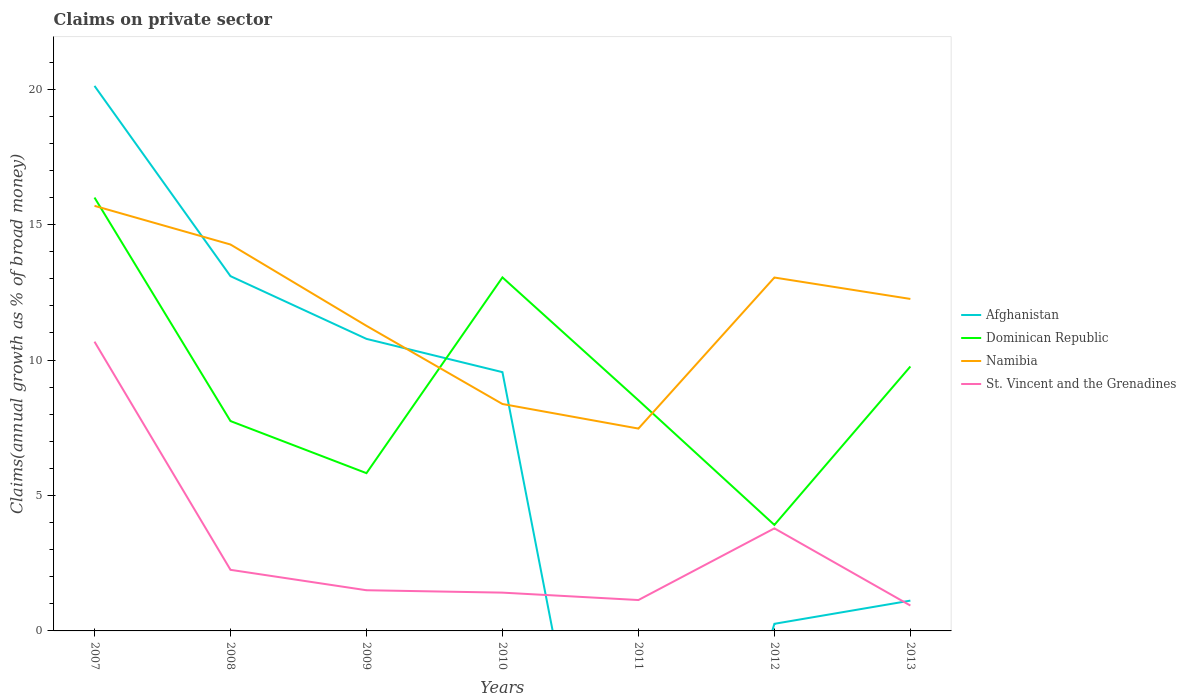Does the line corresponding to Dominican Republic intersect with the line corresponding to St. Vincent and the Grenadines?
Keep it short and to the point. No. Across all years, what is the maximum percentage of broad money claimed on private sector in Namibia?
Keep it short and to the point. 7.47. What is the total percentage of broad money claimed on private sector in Dominican Republic in the graph?
Keep it short and to the point. -5.85. What is the difference between the highest and the second highest percentage of broad money claimed on private sector in Namibia?
Keep it short and to the point. 8.22. What is the difference between the highest and the lowest percentage of broad money claimed on private sector in Namibia?
Your answer should be compact. 4. Is the percentage of broad money claimed on private sector in Namibia strictly greater than the percentage of broad money claimed on private sector in Afghanistan over the years?
Offer a very short reply. No. What is the difference between two consecutive major ticks on the Y-axis?
Your answer should be very brief. 5. Are the values on the major ticks of Y-axis written in scientific E-notation?
Your answer should be compact. No. Does the graph contain grids?
Your answer should be very brief. No. How are the legend labels stacked?
Keep it short and to the point. Vertical. What is the title of the graph?
Give a very brief answer. Claims on private sector. What is the label or title of the X-axis?
Keep it short and to the point. Years. What is the label or title of the Y-axis?
Your answer should be compact. Claims(annual growth as % of broad money). What is the Claims(annual growth as % of broad money) in Afghanistan in 2007?
Offer a very short reply. 20.12. What is the Claims(annual growth as % of broad money) in Dominican Republic in 2007?
Provide a short and direct response. 16. What is the Claims(annual growth as % of broad money) in Namibia in 2007?
Offer a terse response. 15.69. What is the Claims(annual growth as % of broad money) in St. Vincent and the Grenadines in 2007?
Give a very brief answer. 10.68. What is the Claims(annual growth as % of broad money) of Afghanistan in 2008?
Your response must be concise. 13.1. What is the Claims(annual growth as % of broad money) of Dominican Republic in 2008?
Offer a terse response. 7.75. What is the Claims(annual growth as % of broad money) in Namibia in 2008?
Give a very brief answer. 14.27. What is the Claims(annual growth as % of broad money) of St. Vincent and the Grenadines in 2008?
Your answer should be compact. 2.26. What is the Claims(annual growth as % of broad money) in Afghanistan in 2009?
Provide a succinct answer. 10.78. What is the Claims(annual growth as % of broad money) in Dominican Republic in 2009?
Ensure brevity in your answer.  5.82. What is the Claims(annual growth as % of broad money) in Namibia in 2009?
Your answer should be compact. 11.26. What is the Claims(annual growth as % of broad money) in St. Vincent and the Grenadines in 2009?
Your answer should be compact. 1.5. What is the Claims(annual growth as % of broad money) of Afghanistan in 2010?
Offer a very short reply. 9.55. What is the Claims(annual growth as % of broad money) of Dominican Republic in 2010?
Offer a very short reply. 13.05. What is the Claims(annual growth as % of broad money) of Namibia in 2010?
Your answer should be compact. 8.38. What is the Claims(annual growth as % of broad money) in St. Vincent and the Grenadines in 2010?
Keep it short and to the point. 1.41. What is the Claims(annual growth as % of broad money) of Afghanistan in 2011?
Keep it short and to the point. 0. What is the Claims(annual growth as % of broad money) in Dominican Republic in 2011?
Your response must be concise. 8.51. What is the Claims(annual growth as % of broad money) of Namibia in 2011?
Keep it short and to the point. 7.47. What is the Claims(annual growth as % of broad money) of St. Vincent and the Grenadines in 2011?
Provide a short and direct response. 1.14. What is the Claims(annual growth as % of broad money) of Afghanistan in 2012?
Make the answer very short. 0.26. What is the Claims(annual growth as % of broad money) of Dominican Republic in 2012?
Provide a short and direct response. 3.91. What is the Claims(annual growth as % of broad money) in Namibia in 2012?
Offer a terse response. 13.05. What is the Claims(annual growth as % of broad money) in St. Vincent and the Grenadines in 2012?
Your response must be concise. 3.79. What is the Claims(annual growth as % of broad money) of Afghanistan in 2013?
Keep it short and to the point. 1.12. What is the Claims(annual growth as % of broad money) in Dominican Republic in 2013?
Your answer should be very brief. 9.76. What is the Claims(annual growth as % of broad money) in Namibia in 2013?
Give a very brief answer. 12.26. What is the Claims(annual growth as % of broad money) of St. Vincent and the Grenadines in 2013?
Offer a very short reply. 0.94. Across all years, what is the maximum Claims(annual growth as % of broad money) in Afghanistan?
Ensure brevity in your answer.  20.12. Across all years, what is the maximum Claims(annual growth as % of broad money) in Dominican Republic?
Your answer should be very brief. 16. Across all years, what is the maximum Claims(annual growth as % of broad money) in Namibia?
Offer a terse response. 15.69. Across all years, what is the maximum Claims(annual growth as % of broad money) of St. Vincent and the Grenadines?
Give a very brief answer. 10.68. Across all years, what is the minimum Claims(annual growth as % of broad money) in Afghanistan?
Provide a short and direct response. 0. Across all years, what is the minimum Claims(annual growth as % of broad money) in Dominican Republic?
Your answer should be very brief. 3.91. Across all years, what is the minimum Claims(annual growth as % of broad money) of Namibia?
Make the answer very short. 7.47. Across all years, what is the minimum Claims(annual growth as % of broad money) of St. Vincent and the Grenadines?
Provide a short and direct response. 0.94. What is the total Claims(annual growth as % of broad money) in Afghanistan in the graph?
Provide a short and direct response. 54.93. What is the total Claims(annual growth as % of broad money) in Dominican Republic in the graph?
Make the answer very short. 64.81. What is the total Claims(annual growth as % of broad money) of Namibia in the graph?
Your answer should be compact. 82.37. What is the total Claims(annual growth as % of broad money) of St. Vincent and the Grenadines in the graph?
Your answer should be compact. 21.71. What is the difference between the Claims(annual growth as % of broad money) in Afghanistan in 2007 and that in 2008?
Your answer should be compact. 7.02. What is the difference between the Claims(annual growth as % of broad money) in Dominican Republic in 2007 and that in 2008?
Give a very brief answer. 8.25. What is the difference between the Claims(annual growth as % of broad money) of Namibia in 2007 and that in 2008?
Your answer should be compact. 1.43. What is the difference between the Claims(annual growth as % of broad money) in St. Vincent and the Grenadines in 2007 and that in 2008?
Provide a succinct answer. 8.42. What is the difference between the Claims(annual growth as % of broad money) in Afghanistan in 2007 and that in 2009?
Keep it short and to the point. 9.34. What is the difference between the Claims(annual growth as % of broad money) in Dominican Republic in 2007 and that in 2009?
Keep it short and to the point. 10.17. What is the difference between the Claims(annual growth as % of broad money) of Namibia in 2007 and that in 2009?
Provide a short and direct response. 4.43. What is the difference between the Claims(annual growth as % of broad money) of St. Vincent and the Grenadines in 2007 and that in 2009?
Ensure brevity in your answer.  9.18. What is the difference between the Claims(annual growth as % of broad money) in Afghanistan in 2007 and that in 2010?
Offer a terse response. 10.57. What is the difference between the Claims(annual growth as % of broad money) in Dominican Republic in 2007 and that in 2010?
Make the answer very short. 2.95. What is the difference between the Claims(annual growth as % of broad money) of Namibia in 2007 and that in 2010?
Offer a terse response. 7.32. What is the difference between the Claims(annual growth as % of broad money) in St. Vincent and the Grenadines in 2007 and that in 2010?
Offer a very short reply. 9.26. What is the difference between the Claims(annual growth as % of broad money) in Dominican Republic in 2007 and that in 2011?
Offer a very short reply. 7.48. What is the difference between the Claims(annual growth as % of broad money) in Namibia in 2007 and that in 2011?
Make the answer very short. 8.22. What is the difference between the Claims(annual growth as % of broad money) in St. Vincent and the Grenadines in 2007 and that in 2011?
Provide a succinct answer. 9.54. What is the difference between the Claims(annual growth as % of broad money) of Afghanistan in 2007 and that in 2012?
Your answer should be very brief. 19.86. What is the difference between the Claims(annual growth as % of broad money) in Dominican Republic in 2007 and that in 2012?
Offer a very short reply. 12.09. What is the difference between the Claims(annual growth as % of broad money) of Namibia in 2007 and that in 2012?
Provide a short and direct response. 2.65. What is the difference between the Claims(annual growth as % of broad money) in St. Vincent and the Grenadines in 2007 and that in 2012?
Your response must be concise. 6.89. What is the difference between the Claims(annual growth as % of broad money) of Afghanistan in 2007 and that in 2013?
Provide a succinct answer. 19. What is the difference between the Claims(annual growth as % of broad money) of Dominican Republic in 2007 and that in 2013?
Provide a short and direct response. 6.24. What is the difference between the Claims(annual growth as % of broad money) in Namibia in 2007 and that in 2013?
Your answer should be compact. 3.44. What is the difference between the Claims(annual growth as % of broad money) of St. Vincent and the Grenadines in 2007 and that in 2013?
Your answer should be compact. 9.74. What is the difference between the Claims(annual growth as % of broad money) in Afghanistan in 2008 and that in 2009?
Your response must be concise. 2.31. What is the difference between the Claims(annual growth as % of broad money) in Dominican Republic in 2008 and that in 2009?
Keep it short and to the point. 1.92. What is the difference between the Claims(annual growth as % of broad money) of Namibia in 2008 and that in 2009?
Your answer should be compact. 3. What is the difference between the Claims(annual growth as % of broad money) in St. Vincent and the Grenadines in 2008 and that in 2009?
Offer a very short reply. 0.75. What is the difference between the Claims(annual growth as % of broad money) in Afghanistan in 2008 and that in 2010?
Provide a succinct answer. 3.54. What is the difference between the Claims(annual growth as % of broad money) in Dominican Republic in 2008 and that in 2010?
Your answer should be compact. -5.3. What is the difference between the Claims(annual growth as % of broad money) of Namibia in 2008 and that in 2010?
Your response must be concise. 5.89. What is the difference between the Claims(annual growth as % of broad money) in St. Vincent and the Grenadines in 2008 and that in 2010?
Make the answer very short. 0.84. What is the difference between the Claims(annual growth as % of broad money) of Dominican Republic in 2008 and that in 2011?
Provide a short and direct response. -0.77. What is the difference between the Claims(annual growth as % of broad money) in Namibia in 2008 and that in 2011?
Your response must be concise. 6.8. What is the difference between the Claims(annual growth as % of broad money) in St. Vincent and the Grenadines in 2008 and that in 2011?
Your response must be concise. 1.12. What is the difference between the Claims(annual growth as % of broad money) of Afghanistan in 2008 and that in 2012?
Your answer should be compact. 12.83. What is the difference between the Claims(annual growth as % of broad money) in Dominican Republic in 2008 and that in 2012?
Offer a terse response. 3.83. What is the difference between the Claims(annual growth as % of broad money) of Namibia in 2008 and that in 2012?
Offer a terse response. 1.22. What is the difference between the Claims(annual growth as % of broad money) of St. Vincent and the Grenadines in 2008 and that in 2012?
Your response must be concise. -1.53. What is the difference between the Claims(annual growth as % of broad money) in Afghanistan in 2008 and that in 2013?
Offer a very short reply. 11.98. What is the difference between the Claims(annual growth as % of broad money) in Dominican Republic in 2008 and that in 2013?
Offer a terse response. -2.01. What is the difference between the Claims(annual growth as % of broad money) of Namibia in 2008 and that in 2013?
Keep it short and to the point. 2.01. What is the difference between the Claims(annual growth as % of broad money) in St. Vincent and the Grenadines in 2008 and that in 2013?
Your response must be concise. 1.32. What is the difference between the Claims(annual growth as % of broad money) of Afghanistan in 2009 and that in 2010?
Offer a terse response. 1.23. What is the difference between the Claims(annual growth as % of broad money) in Dominican Republic in 2009 and that in 2010?
Your answer should be compact. -7.23. What is the difference between the Claims(annual growth as % of broad money) of Namibia in 2009 and that in 2010?
Offer a terse response. 2.89. What is the difference between the Claims(annual growth as % of broad money) in St. Vincent and the Grenadines in 2009 and that in 2010?
Provide a succinct answer. 0.09. What is the difference between the Claims(annual growth as % of broad money) in Dominican Republic in 2009 and that in 2011?
Your answer should be very brief. -2.69. What is the difference between the Claims(annual growth as % of broad money) in Namibia in 2009 and that in 2011?
Provide a short and direct response. 3.79. What is the difference between the Claims(annual growth as % of broad money) of St. Vincent and the Grenadines in 2009 and that in 2011?
Offer a terse response. 0.36. What is the difference between the Claims(annual growth as % of broad money) of Afghanistan in 2009 and that in 2012?
Provide a succinct answer. 10.52. What is the difference between the Claims(annual growth as % of broad money) in Dominican Republic in 2009 and that in 2012?
Give a very brief answer. 1.91. What is the difference between the Claims(annual growth as % of broad money) in Namibia in 2009 and that in 2012?
Your answer should be very brief. -1.78. What is the difference between the Claims(annual growth as % of broad money) of St. Vincent and the Grenadines in 2009 and that in 2012?
Your answer should be very brief. -2.28. What is the difference between the Claims(annual growth as % of broad money) in Afghanistan in 2009 and that in 2013?
Offer a very short reply. 9.66. What is the difference between the Claims(annual growth as % of broad money) in Dominican Republic in 2009 and that in 2013?
Provide a succinct answer. -3.94. What is the difference between the Claims(annual growth as % of broad money) in Namibia in 2009 and that in 2013?
Your response must be concise. -0.99. What is the difference between the Claims(annual growth as % of broad money) of St. Vincent and the Grenadines in 2009 and that in 2013?
Offer a terse response. 0.56. What is the difference between the Claims(annual growth as % of broad money) of Dominican Republic in 2010 and that in 2011?
Your answer should be very brief. 4.54. What is the difference between the Claims(annual growth as % of broad money) of Namibia in 2010 and that in 2011?
Your response must be concise. 0.91. What is the difference between the Claims(annual growth as % of broad money) of St. Vincent and the Grenadines in 2010 and that in 2011?
Your response must be concise. 0.27. What is the difference between the Claims(annual growth as % of broad money) in Afghanistan in 2010 and that in 2012?
Give a very brief answer. 9.29. What is the difference between the Claims(annual growth as % of broad money) in Dominican Republic in 2010 and that in 2012?
Offer a very short reply. 9.14. What is the difference between the Claims(annual growth as % of broad money) of Namibia in 2010 and that in 2012?
Provide a succinct answer. -4.67. What is the difference between the Claims(annual growth as % of broad money) in St. Vincent and the Grenadines in 2010 and that in 2012?
Give a very brief answer. -2.37. What is the difference between the Claims(annual growth as % of broad money) in Afghanistan in 2010 and that in 2013?
Your response must be concise. 8.43. What is the difference between the Claims(annual growth as % of broad money) of Dominican Republic in 2010 and that in 2013?
Give a very brief answer. 3.29. What is the difference between the Claims(annual growth as % of broad money) in Namibia in 2010 and that in 2013?
Ensure brevity in your answer.  -3.88. What is the difference between the Claims(annual growth as % of broad money) in St. Vincent and the Grenadines in 2010 and that in 2013?
Ensure brevity in your answer.  0.48. What is the difference between the Claims(annual growth as % of broad money) in Dominican Republic in 2011 and that in 2012?
Offer a terse response. 4.6. What is the difference between the Claims(annual growth as % of broad money) of Namibia in 2011 and that in 2012?
Make the answer very short. -5.58. What is the difference between the Claims(annual growth as % of broad money) in St. Vincent and the Grenadines in 2011 and that in 2012?
Provide a succinct answer. -2.65. What is the difference between the Claims(annual growth as % of broad money) of Dominican Republic in 2011 and that in 2013?
Provide a short and direct response. -1.25. What is the difference between the Claims(annual growth as % of broad money) of Namibia in 2011 and that in 2013?
Your answer should be compact. -4.79. What is the difference between the Claims(annual growth as % of broad money) in St. Vincent and the Grenadines in 2011 and that in 2013?
Your response must be concise. 0.2. What is the difference between the Claims(annual growth as % of broad money) of Afghanistan in 2012 and that in 2013?
Your answer should be compact. -0.86. What is the difference between the Claims(annual growth as % of broad money) of Dominican Republic in 2012 and that in 2013?
Give a very brief answer. -5.85. What is the difference between the Claims(annual growth as % of broad money) in Namibia in 2012 and that in 2013?
Your answer should be very brief. 0.79. What is the difference between the Claims(annual growth as % of broad money) in St. Vincent and the Grenadines in 2012 and that in 2013?
Your answer should be compact. 2.85. What is the difference between the Claims(annual growth as % of broad money) in Afghanistan in 2007 and the Claims(annual growth as % of broad money) in Dominican Republic in 2008?
Give a very brief answer. 12.37. What is the difference between the Claims(annual growth as % of broad money) in Afghanistan in 2007 and the Claims(annual growth as % of broad money) in Namibia in 2008?
Your answer should be very brief. 5.85. What is the difference between the Claims(annual growth as % of broad money) in Afghanistan in 2007 and the Claims(annual growth as % of broad money) in St. Vincent and the Grenadines in 2008?
Offer a terse response. 17.86. What is the difference between the Claims(annual growth as % of broad money) of Dominican Republic in 2007 and the Claims(annual growth as % of broad money) of Namibia in 2008?
Provide a succinct answer. 1.73. What is the difference between the Claims(annual growth as % of broad money) of Dominican Republic in 2007 and the Claims(annual growth as % of broad money) of St. Vincent and the Grenadines in 2008?
Make the answer very short. 13.74. What is the difference between the Claims(annual growth as % of broad money) in Namibia in 2007 and the Claims(annual growth as % of broad money) in St. Vincent and the Grenadines in 2008?
Provide a succinct answer. 13.44. What is the difference between the Claims(annual growth as % of broad money) of Afghanistan in 2007 and the Claims(annual growth as % of broad money) of Dominican Republic in 2009?
Ensure brevity in your answer.  14.3. What is the difference between the Claims(annual growth as % of broad money) of Afghanistan in 2007 and the Claims(annual growth as % of broad money) of Namibia in 2009?
Provide a short and direct response. 8.86. What is the difference between the Claims(annual growth as % of broad money) of Afghanistan in 2007 and the Claims(annual growth as % of broad money) of St. Vincent and the Grenadines in 2009?
Give a very brief answer. 18.62. What is the difference between the Claims(annual growth as % of broad money) of Dominican Republic in 2007 and the Claims(annual growth as % of broad money) of Namibia in 2009?
Your answer should be compact. 4.74. What is the difference between the Claims(annual growth as % of broad money) of Dominican Republic in 2007 and the Claims(annual growth as % of broad money) of St. Vincent and the Grenadines in 2009?
Your answer should be very brief. 14.5. What is the difference between the Claims(annual growth as % of broad money) in Namibia in 2007 and the Claims(annual growth as % of broad money) in St. Vincent and the Grenadines in 2009?
Offer a very short reply. 14.19. What is the difference between the Claims(annual growth as % of broad money) in Afghanistan in 2007 and the Claims(annual growth as % of broad money) in Dominican Republic in 2010?
Keep it short and to the point. 7.07. What is the difference between the Claims(annual growth as % of broad money) of Afghanistan in 2007 and the Claims(annual growth as % of broad money) of Namibia in 2010?
Offer a very short reply. 11.74. What is the difference between the Claims(annual growth as % of broad money) in Afghanistan in 2007 and the Claims(annual growth as % of broad money) in St. Vincent and the Grenadines in 2010?
Your answer should be compact. 18.71. What is the difference between the Claims(annual growth as % of broad money) of Dominican Republic in 2007 and the Claims(annual growth as % of broad money) of Namibia in 2010?
Your answer should be compact. 7.62. What is the difference between the Claims(annual growth as % of broad money) in Dominican Republic in 2007 and the Claims(annual growth as % of broad money) in St. Vincent and the Grenadines in 2010?
Offer a very short reply. 14.58. What is the difference between the Claims(annual growth as % of broad money) of Namibia in 2007 and the Claims(annual growth as % of broad money) of St. Vincent and the Grenadines in 2010?
Offer a very short reply. 14.28. What is the difference between the Claims(annual growth as % of broad money) of Afghanistan in 2007 and the Claims(annual growth as % of broad money) of Dominican Republic in 2011?
Offer a very short reply. 11.61. What is the difference between the Claims(annual growth as % of broad money) in Afghanistan in 2007 and the Claims(annual growth as % of broad money) in Namibia in 2011?
Your answer should be compact. 12.65. What is the difference between the Claims(annual growth as % of broad money) in Afghanistan in 2007 and the Claims(annual growth as % of broad money) in St. Vincent and the Grenadines in 2011?
Your answer should be very brief. 18.98. What is the difference between the Claims(annual growth as % of broad money) in Dominican Republic in 2007 and the Claims(annual growth as % of broad money) in Namibia in 2011?
Your answer should be very brief. 8.53. What is the difference between the Claims(annual growth as % of broad money) of Dominican Republic in 2007 and the Claims(annual growth as % of broad money) of St. Vincent and the Grenadines in 2011?
Your answer should be compact. 14.86. What is the difference between the Claims(annual growth as % of broad money) in Namibia in 2007 and the Claims(annual growth as % of broad money) in St. Vincent and the Grenadines in 2011?
Your answer should be compact. 14.55. What is the difference between the Claims(annual growth as % of broad money) of Afghanistan in 2007 and the Claims(annual growth as % of broad money) of Dominican Republic in 2012?
Give a very brief answer. 16.21. What is the difference between the Claims(annual growth as % of broad money) of Afghanistan in 2007 and the Claims(annual growth as % of broad money) of Namibia in 2012?
Give a very brief answer. 7.07. What is the difference between the Claims(annual growth as % of broad money) of Afghanistan in 2007 and the Claims(annual growth as % of broad money) of St. Vincent and the Grenadines in 2012?
Your answer should be very brief. 16.33. What is the difference between the Claims(annual growth as % of broad money) in Dominican Republic in 2007 and the Claims(annual growth as % of broad money) in Namibia in 2012?
Your answer should be very brief. 2.95. What is the difference between the Claims(annual growth as % of broad money) in Dominican Republic in 2007 and the Claims(annual growth as % of broad money) in St. Vincent and the Grenadines in 2012?
Your response must be concise. 12.21. What is the difference between the Claims(annual growth as % of broad money) of Namibia in 2007 and the Claims(annual growth as % of broad money) of St. Vincent and the Grenadines in 2012?
Offer a terse response. 11.91. What is the difference between the Claims(annual growth as % of broad money) of Afghanistan in 2007 and the Claims(annual growth as % of broad money) of Dominican Republic in 2013?
Ensure brevity in your answer.  10.36. What is the difference between the Claims(annual growth as % of broad money) in Afghanistan in 2007 and the Claims(annual growth as % of broad money) in Namibia in 2013?
Make the answer very short. 7.86. What is the difference between the Claims(annual growth as % of broad money) of Afghanistan in 2007 and the Claims(annual growth as % of broad money) of St. Vincent and the Grenadines in 2013?
Your response must be concise. 19.18. What is the difference between the Claims(annual growth as % of broad money) in Dominican Republic in 2007 and the Claims(annual growth as % of broad money) in Namibia in 2013?
Your response must be concise. 3.74. What is the difference between the Claims(annual growth as % of broad money) of Dominican Republic in 2007 and the Claims(annual growth as % of broad money) of St. Vincent and the Grenadines in 2013?
Offer a terse response. 15.06. What is the difference between the Claims(annual growth as % of broad money) of Namibia in 2007 and the Claims(annual growth as % of broad money) of St. Vincent and the Grenadines in 2013?
Make the answer very short. 14.76. What is the difference between the Claims(annual growth as % of broad money) in Afghanistan in 2008 and the Claims(annual growth as % of broad money) in Dominican Republic in 2009?
Make the answer very short. 7.27. What is the difference between the Claims(annual growth as % of broad money) in Afghanistan in 2008 and the Claims(annual growth as % of broad money) in Namibia in 2009?
Offer a terse response. 1.83. What is the difference between the Claims(annual growth as % of broad money) of Afghanistan in 2008 and the Claims(annual growth as % of broad money) of St. Vincent and the Grenadines in 2009?
Provide a short and direct response. 11.59. What is the difference between the Claims(annual growth as % of broad money) in Dominican Republic in 2008 and the Claims(annual growth as % of broad money) in Namibia in 2009?
Your response must be concise. -3.52. What is the difference between the Claims(annual growth as % of broad money) in Dominican Republic in 2008 and the Claims(annual growth as % of broad money) in St. Vincent and the Grenadines in 2009?
Your response must be concise. 6.25. What is the difference between the Claims(annual growth as % of broad money) in Namibia in 2008 and the Claims(annual growth as % of broad money) in St. Vincent and the Grenadines in 2009?
Offer a terse response. 12.76. What is the difference between the Claims(annual growth as % of broad money) of Afghanistan in 2008 and the Claims(annual growth as % of broad money) of Dominican Republic in 2010?
Your answer should be very brief. 0.05. What is the difference between the Claims(annual growth as % of broad money) of Afghanistan in 2008 and the Claims(annual growth as % of broad money) of Namibia in 2010?
Offer a terse response. 4.72. What is the difference between the Claims(annual growth as % of broad money) of Afghanistan in 2008 and the Claims(annual growth as % of broad money) of St. Vincent and the Grenadines in 2010?
Offer a very short reply. 11.68. What is the difference between the Claims(annual growth as % of broad money) in Dominican Republic in 2008 and the Claims(annual growth as % of broad money) in Namibia in 2010?
Keep it short and to the point. -0.63. What is the difference between the Claims(annual growth as % of broad money) of Dominican Republic in 2008 and the Claims(annual growth as % of broad money) of St. Vincent and the Grenadines in 2010?
Provide a succinct answer. 6.33. What is the difference between the Claims(annual growth as % of broad money) in Namibia in 2008 and the Claims(annual growth as % of broad money) in St. Vincent and the Grenadines in 2010?
Your response must be concise. 12.85. What is the difference between the Claims(annual growth as % of broad money) in Afghanistan in 2008 and the Claims(annual growth as % of broad money) in Dominican Republic in 2011?
Your response must be concise. 4.58. What is the difference between the Claims(annual growth as % of broad money) in Afghanistan in 2008 and the Claims(annual growth as % of broad money) in Namibia in 2011?
Keep it short and to the point. 5.63. What is the difference between the Claims(annual growth as % of broad money) of Afghanistan in 2008 and the Claims(annual growth as % of broad money) of St. Vincent and the Grenadines in 2011?
Provide a succinct answer. 11.96. What is the difference between the Claims(annual growth as % of broad money) of Dominican Republic in 2008 and the Claims(annual growth as % of broad money) of Namibia in 2011?
Ensure brevity in your answer.  0.28. What is the difference between the Claims(annual growth as % of broad money) of Dominican Republic in 2008 and the Claims(annual growth as % of broad money) of St. Vincent and the Grenadines in 2011?
Give a very brief answer. 6.61. What is the difference between the Claims(annual growth as % of broad money) in Namibia in 2008 and the Claims(annual growth as % of broad money) in St. Vincent and the Grenadines in 2011?
Your answer should be very brief. 13.12. What is the difference between the Claims(annual growth as % of broad money) in Afghanistan in 2008 and the Claims(annual growth as % of broad money) in Dominican Republic in 2012?
Keep it short and to the point. 9.18. What is the difference between the Claims(annual growth as % of broad money) of Afghanistan in 2008 and the Claims(annual growth as % of broad money) of Namibia in 2012?
Give a very brief answer. 0.05. What is the difference between the Claims(annual growth as % of broad money) in Afghanistan in 2008 and the Claims(annual growth as % of broad money) in St. Vincent and the Grenadines in 2012?
Offer a terse response. 9.31. What is the difference between the Claims(annual growth as % of broad money) of Dominican Republic in 2008 and the Claims(annual growth as % of broad money) of Namibia in 2012?
Give a very brief answer. -5.3. What is the difference between the Claims(annual growth as % of broad money) of Dominican Republic in 2008 and the Claims(annual growth as % of broad money) of St. Vincent and the Grenadines in 2012?
Keep it short and to the point. 3.96. What is the difference between the Claims(annual growth as % of broad money) in Namibia in 2008 and the Claims(annual growth as % of broad money) in St. Vincent and the Grenadines in 2012?
Provide a succinct answer. 10.48. What is the difference between the Claims(annual growth as % of broad money) of Afghanistan in 2008 and the Claims(annual growth as % of broad money) of Dominican Republic in 2013?
Offer a very short reply. 3.33. What is the difference between the Claims(annual growth as % of broad money) of Afghanistan in 2008 and the Claims(annual growth as % of broad money) of Namibia in 2013?
Make the answer very short. 0.84. What is the difference between the Claims(annual growth as % of broad money) in Afghanistan in 2008 and the Claims(annual growth as % of broad money) in St. Vincent and the Grenadines in 2013?
Your response must be concise. 12.16. What is the difference between the Claims(annual growth as % of broad money) of Dominican Republic in 2008 and the Claims(annual growth as % of broad money) of Namibia in 2013?
Ensure brevity in your answer.  -4.51. What is the difference between the Claims(annual growth as % of broad money) in Dominican Republic in 2008 and the Claims(annual growth as % of broad money) in St. Vincent and the Grenadines in 2013?
Your response must be concise. 6.81. What is the difference between the Claims(annual growth as % of broad money) of Namibia in 2008 and the Claims(annual growth as % of broad money) of St. Vincent and the Grenadines in 2013?
Provide a succinct answer. 13.33. What is the difference between the Claims(annual growth as % of broad money) of Afghanistan in 2009 and the Claims(annual growth as % of broad money) of Dominican Republic in 2010?
Your answer should be very brief. -2.27. What is the difference between the Claims(annual growth as % of broad money) in Afghanistan in 2009 and the Claims(annual growth as % of broad money) in Namibia in 2010?
Offer a very short reply. 2.4. What is the difference between the Claims(annual growth as % of broad money) of Afghanistan in 2009 and the Claims(annual growth as % of broad money) of St. Vincent and the Grenadines in 2010?
Your answer should be compact. 9.37. What is the difference between the Claims(annual growth as % of broad money) of Dominican Republic in 2009 and the Claims(annual growth as % of broad money) of Namibia in 2010?
Provide a short and direct response. -2.55. What is the difference between the Claims(annual growth as % of broad money) of Dominican Republic in 2009 and the Claims(annual growth as % of broad money) of St. Vincent and the Grenadines in 2010?
Make the answer very short. 4.41. What is the difference between the Claims(annual growth as % of broad money) in Namibia in 2009 and the Claims(annual growth as % of broad money) in St. Vincent and the Grenadines in 2010?
Keep it short and to the point. 9.85. What is the difference between the Claims(annual growth as % of broad money) of Afghanistan in 2009 and the Claims(annual growth as % of broad money) of Dominican Republic in 2011?
Offer a very short reply. 2.27. What is the difference between the Claims(annual growth as % of broad money) in Afghanistan in 2009 and the Claims(annual growth as % of broad money) in Namibia in 2011?
Your answer should be very brief. 3.31. What is the difference between the Claims(annual growth as % of broad money) of Afghanistan in 2009 and the Claims(annual growth as % of broad money) of St. Vincent and the Grenadines in 2011?
Offer a terse response. 9.64. What is the difference between the Claims(annual growth as % of broad money) in Dominican Republic in 2009 and the Claims(annual growth as % of broad money) in Namibia in 2011?
Your answer should be very brief. -1.65. What is the difference between the Claims(annual growth as % of broad money) in Dominican Republic in 2009 and the Claims(annual growth as % of broad money) in St. Vincent and the Grenadines in 2011?
Make the answer very short. 4.68. What is the difference between the Claims(annual growth as % of broad money) of Namibia in 2009 and the Claims(annual growth as % of broad money) of St. Vincent and the Grenadines in 2011?
Your response must be concise. 10.12. What is the difference between the Claims(annual growth as % of broad money) of Afghanistan in 2009 and the Claims(annual growth as % of broad money) of Dominican Republic in 2012?
Keep it short and to the point. 6.87. What is the difference between the Claims(annual growth as % of broad money) in Afghanistan in 2009 and the Claims(annual growth as % of broad money) in Namibia in 2012?
Your response must be concise. -2.26. What is the difference between the Claims(annual growth as % of broad money) in Afghanistan in 2009 and the Claims(annual growth as % of broad money) in St. Vincent and the Grenadines in 2012?
Offer a terse response. 6.99. What is the difference between the Claims(annual growth as % of broad money) in Dominican Republic in 2009 and the Claims(annual growth as % of broad money) in Namibia in 2012?
Keep it short and to the point. -7.22. What is the difference between the Claims(annual growth as % of broad money) of Dominican Republic in 2009 and the Claims(annual growth as % of broad money) of St. Vincent and the Grenadines in 2012?
Offer a terse response. 2.04. What is the difference between the Claims(annual growth as % of broad money) in Namibia in 2009 and the Claims(annual growth as % of broad money) in St. Vincent and the Grenadines in 2012?
Give a very brief answer. 7.48. What is the difference between the Claims(annual growth as % of broad money) in Afghanistan in 2009 and the Claims(annual growth as % of broad money) in Dominican Republic in 2013?
Your response must be concise. 1.02. What is the difference between the Claims(annual growth as % of broad money) in Afghanistan in 2009 and the Claims(annual growth as % of broad money) in Namibia in 2013?
Offer a terse response. -1.47. What is the difference between the Claims(annual growth as % of broad money) in Afghanistan in 2009 and the Claims(annual growth as % of broad money) in St. Vincent and the Grenadines in 2013?
Give a very brief answer. 9.84. What is the difference between the Claims(annual growth as % of broad money) in Dominican Republic in 2009 and the Claims(annual growth as % of broad money) in Namibia in 2013?
Ensure brevity in your answer.  -6.43. What is the difference between the Claims(annual growth as % of broad money) of Dominican Republic in 2009 and the Claims(annual growth as % of broad money) of St. Vincent and the Grenadines in 2013?
Make the answer very short. 4.89. What is the difference between the Claims(annual growth as % of broad money) in Namibia in 2009 and the Claims(annual growth as % of broad money) in St. Vincent and the Grenadines in 2013?
Provide a short and direct response. 10.33. What is the difference between the Claims(annual growth as % of broad money) in Afghanistan in 2010 and the Claims(annual growth as % of broad money) in Namibia in 2011?
Your answer should be compact. 2.08. What is the difference between the Claims(annual growth as % of broad money) in Afghanistan in 2010 and the Claims(annual growth as % of broad money) in St. Vincent and the Grenadines in 2011?
Ensure brevity in your answer.  8.41. What is the difference between the Claims(annual growth as % of broad money) in Dominican Republic in 2010 and the Claims(annual growth as % of broad money) in Namibia in 2011?
Your answer should be very brief. 5.58. What is the difference between the Claims(annual growth as % of broad money) in Dominican Republic in 2010 and the Claims(annual growth as % of broad money) in St. Vincent and the Grenadines in 2011?
Give a very brief answer. 11.91. What is the difference between the Claims(annual growth as % of broad money) of Namibia in 2010 and the Claims(annual growth as % of broad money) of St. Vincent and the Grenadines in 2011?
Offer a very short reply. 7.24. What is the difference between the Claims(annual growth as % of broad money) of Afghanistan in 2010 and the Claims(annual growth as % of broad money) of Dominican Republic in 2012?
Provide a short and direct response. 5.64. What is the difference between the Claims(annual growth as % of broad money) in Afghanistan in 2010 and the Claims(annual growth as % of broad money) in Namibia in 2012?
Your answer should be compact. -3.49. What is the difference between the Claims(annual growth as % of broad money) of Afghanistan in 2010 and the Claims(annual growth as % of broad money) of St. Vincent and the Grenadines in 2012?
Your response must be concise. 5.77. What is the difference between the Claims(annual growth as % of broad money) in Dominican Republic in 2010 and the Claims(annual growth as % of broad money) in Namibia in 2012?
Ensure brevity in your answer.  0.01. What is the difference between the Claims(annual growth as % of broad money) in Dominican Republic in 2010 and the Claims(annual growth as % of broad money) in St. Vincent and the Grenadines in 2012?
Offer a terse response. 9.26. What is the difference between the Claims(annual growth as % of broad money) in Namibia in 2010 and the Claims(annual growth as % of broad money) in St. Vincent and the Grenadines in 2012?
Your answer should be compact. 4.59. What is the difference between the Claims(annual growth as % of broad money) of Afghanistan in 2010 and the Claims(annual growth as % of broad money) of Dominican Republic in 2013?
Your answer should be very brief. -0.21. What is the difference between the Claims(annual growth as % of broad money) of Afghanistan in 2010 and the Claims(annual growth as % of broad money) of Namibia in 2013?
Your answer should be compact. -2.7. What is the difference between the Claims(annual growth as % of broad money) of Afghanistan in 2010 and the Claims(annual growth as % of broad money) of St. Vincent and the Grenadines in 2013?
Give a very brief answer. 8.62. What is the difference between the Claims(annual growth as % of broad money) in Dominican Republic in 2010 and the Claims(annual growth as % of broad money) in Namibia in 2013?
Your answer should be compact. 0.8. What is the difference between the Claims(annual growth as % of broad money) of Dominican Republic in 2010 and the Claims(annual growth as % of broad money) of St. Vincent and the Grenadines in 2013?
Make the answer very short. 12.11. What is the difference between the Claims(annual growth as % of broad money) of Namibia in 2010 and the Claims(annual growth as % of broad money) of St. Vincent and the Grenadines in 2013?
Make the answer very short. 7.44. What is the difference between the Claims(annual growth as % of broad money) of Dominican Republic in 2011 and the Claims(annual growth as % of broad money) of Namibia in 2012?
Your response must be concise. -4.53. What is the difference between the Claims(annual growth as % of broad money) of Dominican Republic in 2011 and the Claims(annual growth as % of broad money) of St. Vincent and the Grenadines in 2012?
Provide a short and direct response. 4.73. What is the difference between the Claims(annual growth as % of broad money) in Namibia in 2011 and the Claims(annual growth as % of broad money) in St. Vincent and the Grenadines in 2012?
Offer a very short reply. 3.68. What is the difference between the Claims(annual growth as % of broad money) in Dominican Republic in 2011 and the Claims(annual growth as % of broad money) in Namibia in 2013?
Offer a terse response. -3.74. What is the difference between the Claims(annual growth as % of broad money) of Dominican Republic in 2011 and the Claims(annual growth as % of broad money) of St. Vincent and the Grenadines in 2013?
Keep it short and to the point. 7.58. What is the difference between the Claims(annual growth as % of broad money) of Namibia in 2011 and the Claims(annual growth as % of broad money) of St. Vincent and the Grenadines in 2013?
Your answer should be very brief. 6.53. What is the difference between the Claims(annual growth as % of broad money) in Afghanistan in 2012 and the Claims(annual growth as % of broad money) in Dominican Republic in 2013?
Keep it short and to the point. -9.5. What is the difference between the Claims(annual growth as % of broad money) in Afghanistan in 2012 and the Claims(annual growth as % of broad money) in Namibia in 2013?
Provide a short and direct response. -11.99. What is the difference between the Claims(annual growth as % of broad money) in Afghanistan in 2012 and the Claims(annual growth as % of broad money) in St. Vincent and the Grenadines in 2013?
Ensure brevity in your answer.  -0.67. What is the difference between the Claims(annual growth as % of broad money) in Dominican Republic in 2012 and the Claims(annual growth as % of broad money) in Namibia in 2013?
Ensure brevity in your answer.  -8.34. What is the difference between the Claims(annual growth as % of broad money) in Dominican Republic in 2012 and the Claims(annual growth as % of broad money) in St. Vincent and the Grenadines in 2013?
Your response must be concise. 2.98. What is the difference between the Claims(annual growth as % of broad money) of Namibia in 2012 and the Claims(annual growth as % of broad money) of St. Vincent and the Grenadines in 2013?
Offer a terse response. 12.11. What is the average Claims(annual growth as % of broad money) of Afghanistan per year?
Your response must be concise. 7.85. What is the average Claims(annual growth as % of broad money) of Dominican Republic per year?
Offer a very short reply. 9.26. What is the average Claims(annual growth as % of broad money) of Namibia per year?
Your answer should be very brief. 11.77. What is the average Claims(annual growth as % of broad money) of St. Vincent and the Grenadines per year?
Your answer should be very brief. 3.1. In the year 2007, what is the difference between the Claims(annual growth as % of broad money) in Afghanistan and Claims(annual growth as % of broad money) in Dominican Republic?
Keep it short and to the point. 4.12. In the year 2007, what is the difference between the Claims(annual growth as % of broad money) of Afghanistan and Claims(annual growth as % of broad money) of Namibia?
Your response must be concise. 4.43. In the year 2007, what is the difference between the Claims(annual growth as % of broad money) in Afghanistan and Claims(annual growth as % of broad money) in St. Vincent and the Grenadines?
Ensure brevity in your answer.  9.44. In the year 2007, what is the difference between the Claims(annual growth as % of broad money) in Dominican Republic and Claims(annual growth as % of broad money) in Namibia?
Provide a short and direct response. 0.31. In the year 2007, what is the difference between the Claims(annual growth as % of broad money) in Dominican Republic and Claims(annual growth as % of broad money) in St. Vincent and the Grenadines?
Offer a very short reply. 5.32. In the year 2007, what is the difference between the Claims(annual growth as % of broad money) in Namibia and Claims(annual growth as % of broad money) in St. Vincent and the Grenadines?
Keep it short and to the point. 5.01. In the year 2008, what is the difference between the Claims(annual growth as % of broad money) of Afghanistan and Claims(annual growth as % of broad money) of Dominican Republic?
Make the answer very short. 5.35. In the year 2008, what is the difference between the Claims(annual growth as % of broad money) in Afghanistan and Claims(annual growth as % of broad money) in Namibia?
Offer a terse response. -1.17. In the year 2008, what is the difference between the Claims(annual growth as % of broad money) in Afghanistan and Claims(annual growth as % of broad money) in St. Vincent and the Grenadines?
Offer a very short reply. 10.84. In the year 2008, what is the difference between the Claims(annual growth as % of broad money) in Dominican Republic and Claims(annual growth as % of broad money) in Namibia?
Make the answer very short. -6.52. In the year 2008, what is the difference between the Claims(annual growth as % of broad money) of Dominican Republic and Claims(annual growth as % of broad money) of St. Vincent and the Grenadines?
Provide a succinct answer. 5.49. In the year 2008, what is the difference between the Claims(annual growth as % of broad money) of Namibia and Claims(annual growth as % of broad money) of St. Vincent and the Grenadines?
Offer a terse response. 12.01. In the year 2009, what is the difference between the Claims(annual growth as % of broad money) of Afghanistan and Claims(annual growth as % of broad money) of Dominican Republic?
Offer a terse response. 4.96. In the year 2009, what is the difference between the Claims(annual growth as % of broad money) in Afghanistan and Claims(annual growth as % of broad money) in Namibia?
Make the answer very short. -0.48. In the year 2009, what is the difference between the Claims(annual growth as % of broad money) in Afghanistan and Claims(annual growth as % of broad money) in St. Vincent and the Grenadines?
Your answer should be compact. 9.28. In the year 2009, what is the difference between the Claims(annual growth as % of broad money) in Dominican Republic and Claims(annual growth as % of broad money) in Namibia?
Offer a terse response. -5.44. In the year 2009, what is the difference between the Claims(annual growth as % of broad money) in Dominican Republic and Claims(annual growth as % of broad money) in St. Vincent and the Grenadines?
Your answer should be very brief. 4.32. In the year 2009, what is the difference between the Claims(annual growth as % of broad money) in Namibia and Claims(annual growth as % of broad money) in St. Vincent and the Grenadines?
Offer a very short reply. 9.76. In the year 2010, what is the difference between the Claims(annual growth as % of broad money) in Afghanistan and Claims(annual growth as % of broad money) in Dominican Republic?
Your answer should be compact. -3.5. In the year 2010, what is the difference between the Claims(annual growth as % of broad money) of Afghanistan and Claims(annual growth as % of broad money) of Namibia?
Make the answer very short. 1.18. In the year 2010, what is the difference between the Claims(annual growth as % of broad money) in Afghanistan and Claims(annual growth as % of broad money) in St. Vincent and the Grenadines?
Provide a short and direct response. 8.14. In the year 2010, what is the difference between the Claims(annual growth as % of broad money) in Dominican Republic and Claims(annual growth as % of broad money) in Namibia?
Your response must be concise. 4.67. In the year 2010, what is the difference between the Claims(annual growth as % of broad money) in Dominican Republic and Claims(annual growth as % of broad money) in St. Vincent and the Grenadines?
Give a very brief answer. 11.64. In the year 2010, what is the difference between the Claims(annual growth as % of broad money) in Namibia and Claims(annual growth as % of broad money) in St. Vincent and the Grenadines?
Offer a terse response. 6.96. In the year 2011, what is the difference between the Claims(annual growth as % of broad money) in Dominican Republic and Claims(annual growth as % of broad money) in Namibia?
Keep it short and to the point. 1.04. In the year 2011, what is the difference between the Claims(annual growth as % of broad money) of Dominican Republic and Claims(annual growth as % of broad money) of St. Vincent and the Grenadines?
Your answer should be very brief. 7.37. In the year 2011, what is the difference between the Claims(annual growth as % of broad money) in Namibia and Claims(annual growth as % of broad money) in St. Vincent and the Grenadines?
Your response must be concise. 6.33. In the year 2012, what is the difference between the Claims(annual growth as % of broad money) of Afghanistan and Claims(annual growth as % of broad money) of Dominican Republic?
Your answer should be compact. -3.65. In the year 2012, what is the difference between the Claims(annual growth as % of broad money) of Afghanistan and Claims(annual growth as % of broad money) of Namibia?
Your answer should be very brief. -12.78. In the year 2012, what is the difference between the Claims(annual growth as % of broad money) of Afghanistan and Claims(annual growth as % of broad money) of St. Vincent and the Grenadines?
Keep it short and to the point. -3.52. In the year 2012, what is the difference between the Claims(annual growth as % of broad money) of Dominican Republic and Claims(annual growth as % of broad money) of Namibia?
Offer a terse response. -9.13. In the year 2012, what is the difference between the Claims(annual growth as % of broad money) in Dominican Republic and Claims(annual growth as % of broad money) in St. Vincent and the Grenadines?
Give a very brief answer. 0.13. In the year 2012, what is the difference between the Claims(annual growth as % of broad money) in Namibia and Claims(annual growth as % of broad money) in St. Vincent and the Grenadines?
Your response must be concise. 9.26. In the year 2013, what is the difference between the Claims(annual growth as % of broad money) in Afghanistan and Claims(annual growth as % of broad money) in Dominican Republic?
Your answer should be compact. -8.64. In the year 2013, what is the difference between the Claims(annual growth as % of broad money) of Afghanistan and Claims(annual growth as % of broad money) of Namibia?
Your response must be concise. -11.14. In the year 2013, what is the difference between the Claims(annual growth as % of broad money) in Afghanistan and Claims(annual growth as % of broad money) in St. Vincent and the Grenadines?
Offer a very short reply. 0.18. In the year 2013, what is the difference between the Claims(annual growth as % of broad money) of Dominican Republic and Claims(annual growth as % of broad money) of Namibia?
Ensure brevity in your answer.  -2.49. In the year 2013, what is the difference between the Claims(annual growth as % of broad money) of Dominican Republic and Claims(annual growth as % of broad money) of St. Vincent and the Grenadines?
Provide a succinct answer. 8.83. In the year 2013, what is the difference between the Claims(annual growth as % of broad money) of Namibia and Claims(annual growth as % of broad money) of St. Vincent and the Grenadines?
Your answer should be very brief. 11.32. What is the ratio of the Claims(annual growth as % of broad money) of Afghanistan in 2007 to that in 2008?
Keep it short and to the point. 1.54. What is the ratio of the Claims(annual growth as % of broad money) of Dominican Republic in 2007 to that in 2008?
Offer a very short reply. 2.06. What is the ratio of the Claims(annual growth as % of broad money) of Namibia in 2007 to that in 2008?
Give a very brief answer. 1.1. What is the ratio of the Claims(annual growth as % of broad money) in St. Vincent and the Grenadines in 2007 to that in 2008?
Keep it short and to the point. 4.73. What is the ratio of the Claims(annual growth as % of broad money) of Afghanistan in 2007 to that in 2009?
Your answer should be compact. 1.87. What is the ratio of the Claims(annual growth as % of broad money) of Dominican Republic in 2007 to that in 2009?
Your answer should be very brief. 2.75. What is the ratio of the Claims(annual growth as % of broad money) of Namibia in 2007 to that in 2009?
Your answer should be compact. 1.39. What is the ratio of the Claims(annual growth as % of broad money) of St. Vincent and the Grenadines in 2007 to that in 2009?
Your answer should be compact. 7.11. What is the ratio of the Claims(annual growth as % of broad money) of Afghanistan in 2007 to that in 2010?
Provide a succinct answer. 2.11. What is the ratio of the Claims(annual growth as % of broad money) in Dominican Republic in 2007 to that in 2010?
Offer a very short reply. 1.23. What is the ratio of the Claims(annual growth as % of broad money) in Namibia in 2007 to that in 2010?
Provide a succinct answer. 1.87. What is the ratio of the Claims(annual growth as % of broad money) of St. Vincent and the Grenadines in 2007 to that in 2010?
Your answer should be very brief. 7.55. What is the ratio of the Claims(annual growth as % of broad money) in Dominican Republic in 2007 to that in 2011?
Your answer should be compact. 1.88. What is the ratio of the Claims(annual growth as % of broad money) in Namibia in 2007 to that in 2011?
Provide a short and direct response. 2.1. What is the ratio of the Claims(annual growth as % of broad money) in St. Vincent and the Grenadines in 2007 to that in 2011?
Make the answer very short. 9.36. What is the ratio of the Claims(annual growth as % of broad money) of Afghanistan in 2007 to that in 2012?
Keep it short and to the point. 76.71. What is the ratio of the Claims(annual growth as % of broad money) in Dominican Republic in 2007 to that in 2012?
Make the answer very short. 4.09. What is the ratio of the Claims(annual growth as % of broad money) of Namibia in 2007 to that in 2012?
Ensure brevity in your answer.  1.2. What is the ratio of the Claims(annual growth as % of broad money) of St. Vincent and the Grenadines in 2007 to that in 2012?
Offer a very short reply. 2.82. What is the ratio of the Claims(annual growth as % of broad money) in Afghanistan in 2007 to that in 2013?
Make the answer very short. 17.99. What is the ratio of the Claims(annual growth as % of broad money) in Dominican Republic in 2007 to that in 2013?
Offer a very short reply. 1.64. What is the ratio of the Claims(annual growth as % of broad money) in Namibia in 2007 to that in 2013?
Provide a short and direct response. 1.28. What is the ratio of the Claims(annual growth as % of broad money) in St. Vincent and the Grenadines in 2007 to that in 2013?
Your answer should be very brief. 11.4. What is the ratio of the Claims(annual growth as % of broad money) in Afghanistan in 2008 to that in 2009?
Your response must be concise. 1.21. What is the ratio of the Claims(annual growth as % of broad money) of Dominican Republic in 2008 to that in 2009?
Offer a very short reply. 1.33. What is the ratio of the Claims(annual growth as % of broad money) of Namibia in 2008 to that in 2009?
Offer a terse response. 1.27. What is the ratio of the Claims(annual growth as % of broad money) of St. Vincent and the Grenadines in 2008 to that in 2009?
Provide a short and direct response. 1.5. What is the ratio of the Claims(annual growth as % of broad money) in Afghanistan in 2008 to that in 2010?
Provide a short and direct response. 1.37. What is the ratio of the Claims(annual growth as % of broad money) in Dominican Republic in 2008 to that in 2010?
Offer a terse response. 0.59. What is the ratio of the Claims(annual growth as % of broad money) in Namibia in 2008 to that in 2010?
Provide a succinct answer. 1.7. What is the ratio of the Claims(annual growth as % of broad money) in St. Vincent and the Grenadines in 2008 to that in 2010?
Offer a very short reply. 1.6. What is the ratio of the Claims(annual growth as % of broad money) in Dominican Republic in 2008 to that in 2011?
Offer a very short reply. 0.91. What is the ratio of the Claims(annual growth as % of broad money) in Namibia in 2008 to that in 2011?
Your answer should be compact. 1.91. What is the ratio of the Claims(annual growth as % of broad money) of St. Vincent and the Grenadines in 2008 to that in 2011?
Your response must be concise. 1.98. What is the ratio of the Claims(annual growth as % of broad money) in Afghanistan in 2008 to that in 2012?
Your answer should be compact. 49.93. What is the ratio of the Claims(annual growth as % of broad money) in Dominican Republic in 2008 to that in 2012?
Make the answer very short. 1.98. What is the ratio of the Claims(annual growth as % of broad money) of Namibia in 2008 to that in 2012?
Provide a succinct answer. 1.09. What is the ratio of the Claims(annual growth as % of broad money) of St. Vincent and the Grenadines in 2008 to that in 2012?
Your response must be concise. 0.6. What is the ratio of the Claims(annual growth as % of broad money) in Afghanistan in 2008 to that in 2013?
Offer a terse response. 11.71. What is the ratio of the Claims(annual growth as % of broad money) of Dominican Republic in 2008 to that in 2013?
Your answer should be very brief. 0.79. What is the ratio of the Claims(annual growth as % of broad money) in Namibia in 2008 to that in 2013?
Provide a succinct answer. 1.16. What is the ratio of the Claims(annual growth as % of broad money) of St. Vincent and the Grenadines in 2008 to that in 2013?
Your answer should be very brief. 2.41. What is the ratio of the Claims(annual growth as % of broad money) in Afghanistan in 2009 to that in 2010?
Offer a very short reply. 1.13. What is the ratio of the Claims(annual growth as % of broad money) in Dominican Republic in 2009 to that in 2010?
Give a very brief answer. 0.45. What is the ratio of the Claims(annual growth as % of broad money) of Namibia in 2009 to that in 2010?
Provide a succinct answer. 1.34. What is the ratio of the Claims(annual growth as % of broad money) in St. Vincent and the Grenadines in 2009 to that in 2010?
Provide a succinct answer. 1.06. What is the ratio of the Claims(annual growth as % of broad money) of Dominican Republic in 2009 to that in 2011?
Your response must be concise. 0.68. What is the ratio of the Claims(annual growth as % of broad money) of Namibia in 2009 to that in 2011?
Provide a short and direct response. 1.51. What is the ratio of the Claims(annual growth as % of broad money) of St. Vincent and the Grenadines in 2009 to that in 2011?
Ensure brevity in your answer.  1.32. What is the ratio of the Claims(annual growth as % of broad money) of Afghanistan in 2009 to that in 2012?
Your response must be concise. 41.1. What is the ratio of the Claims(annual growth as % of broad money) in Dominican Republic in 2009 to that in 2012?
Your answer should be very brief. 1.49. What is the ratio of the Claims(annual growth as % of broad money) in Namibia in 2009 to that in 2012?
Make the answer very short. 0.86. What is the ratio of the Claims(annual growth as % of broad money) of St. Vincent and the Grenadines in 2009 to that in 2012?
Make the answer very short. 0.4. What is the ratio of the Claims(annual growth as % of broad money) of Afghanistan in 2009 to that in 2013?
Offer a terse response. 9.64. What is the ratio of the Claims(annual growth as % of broad money) of Dominican Republic in 2009 to that in 2013?
Your answer should be very brief. 0.6. What is the ratio of the Claims(annual growth as % of broad money) in Namibia in 2009 to that in 2013?
Make the answer very short. 0.92. What is the ratio of the Claims(annual growth as % of broad money) of St. Vincent and the Grenadines in 2009 to that in 2013?
Ensure brevity in your answer.  1.6. What is the ratio of the Claims(annual growth as % of broad money) of Dominican Republic in 2010 to that in 2011?
Provide a short and direct response. 1.53. What is the ratio of the Claims(annual growth as % of broad money) of Namibia in 2010 to that in 2011?
Keep it short and to the point. 1.12. What is the ratio of the Claims(annual growth as % of broad money) of St. Vincent and the Grenadines in 2010 to that in 2011?
Offer a very short reply. 1.24. What is the ratio of the Claims(annual growth as % of broad money) in Afghanistan in 2010 to that in 2012?
Offer a very short reply. 36.42. What is the ratio of the Claims(annual growth as % of broad money) in Dominican Republic in 2010 to that in 2012?
Offer a very short reply. 3.34. What is the ratio of the Claims(annual growth as % of broad money) in Namibia in 2010 to that in 2012?
Make the answer very short. 0.64. What is the ratio of the Claims(annual growth as % of broad money) in St. Vincent and the Grenadines in 2010 to that in 2012?
Provide a short and direct response. 0.37. What is the ratio of the Claims(annual growth as % of broad money) of Afghanistan in 2010 to that in 2013?
Ensure brevity in your answer.  8.54. What is the ratio of the Claims(annual growth as % of broad money) in Dominican Republic in 2010 to that in 2013?
Provide a succinct answer. 1.34. What is the ratio of the Claims(annual growth as % of broad money) of Namibia in 2010 to that in 2013?
Keep it short and to the point. 0.68. What is the ratio of the Claims(annual growth as % of broad money) of St. Vincent and the Grenadines in 2010 to that in 2013?
Provide a short and direct response. 1.51. What is the ratio of the Claims(annual growth as % of broad money) of Dominican Republic in 2011 to that in 2012?
Your answer should be compact. 2.18. What is the ratio of the Claims(annual growth as % of broad money) in Namibia in 2011 to that in 2012?
Your answer should be compact. 0.57. What is the ratio of the Claims(annual growth as % of broad money) in St. Vincent and the Grenadines in 2011 to that in 2012?
Make the answer very short. 0.3. What is the ratio of the Claims(annual growth as % of broad money) in Dominican Republic in 2011 to that in 2013?
Your answer should be compact. 0.87. What is the ratio of the Claims(annual growth as % of broad money) of Namibia in 2011 to that in 2013?
Ensure brevity in your answer.  0.61. What is the ratio of the Claims(annual growth as % of broad money) in St. Vincent and the Grenadines in 2011 to that in 2013?
Your answer should be very brief. 1.22. What is the ratio of the Claims(annual growth as % of broad money) in Afghanistan in 2012 to that in 2013?
Provide a short and direct response. 0.23. What is the ratio of the Claims(annual growth as % of broad money) of Dominican Republic in 2012 to that in 2013?
Give a very brief answer. 0.4. What is the ratio of the Claims(annual growth as % of broad money) of Namibia in 2012 to that in 2013?
Make the answer very short. 1.06. What is the ratio of the Claims(annual growth as % of broad money) in St. Vincent and the Grenadines in 2012 to that in 2013?
Provide a short and direct response. 4.04. What is the difference between the highest and the second highest Claims(annual growth as % of broad money) of Afghanistan?
Give a very brief answer. 7.02. What is the difference between the highest and the second highest Claims(annual growth as % of broad money) in Dominican Republic?
Offer a terse response. 2.95. What is the difference between the highest and the second highest Claims(annual growth as % of broad money) in Namibia?
Make the answer very short. 1.43. What is the difference between the highest and the second highest Claims(annual growth as % of broad money) of St. Vincent and the Grenadines?
Your answer should be compact. 6.89. What is the difference between the highest and the lowest Claims(annual growth as % of broad money) of Afghanistan?
Keep it short and to the point. 20.12. What is the difference between the highest and the lowest Claims(annual growth as % of broad money) of Dominican Republic?
Your response must be concise. 12.09. What is the difference between the highest and the lowest Claims(annual growth as % of broad money) of Namibia?
Your answer should be very brief. 8.22. What is the difference between the highest and the lowest Claims(annual growth as % of broad money) in St. Vincent and the Grenadines?
Offer a very short reply. 9.74. 